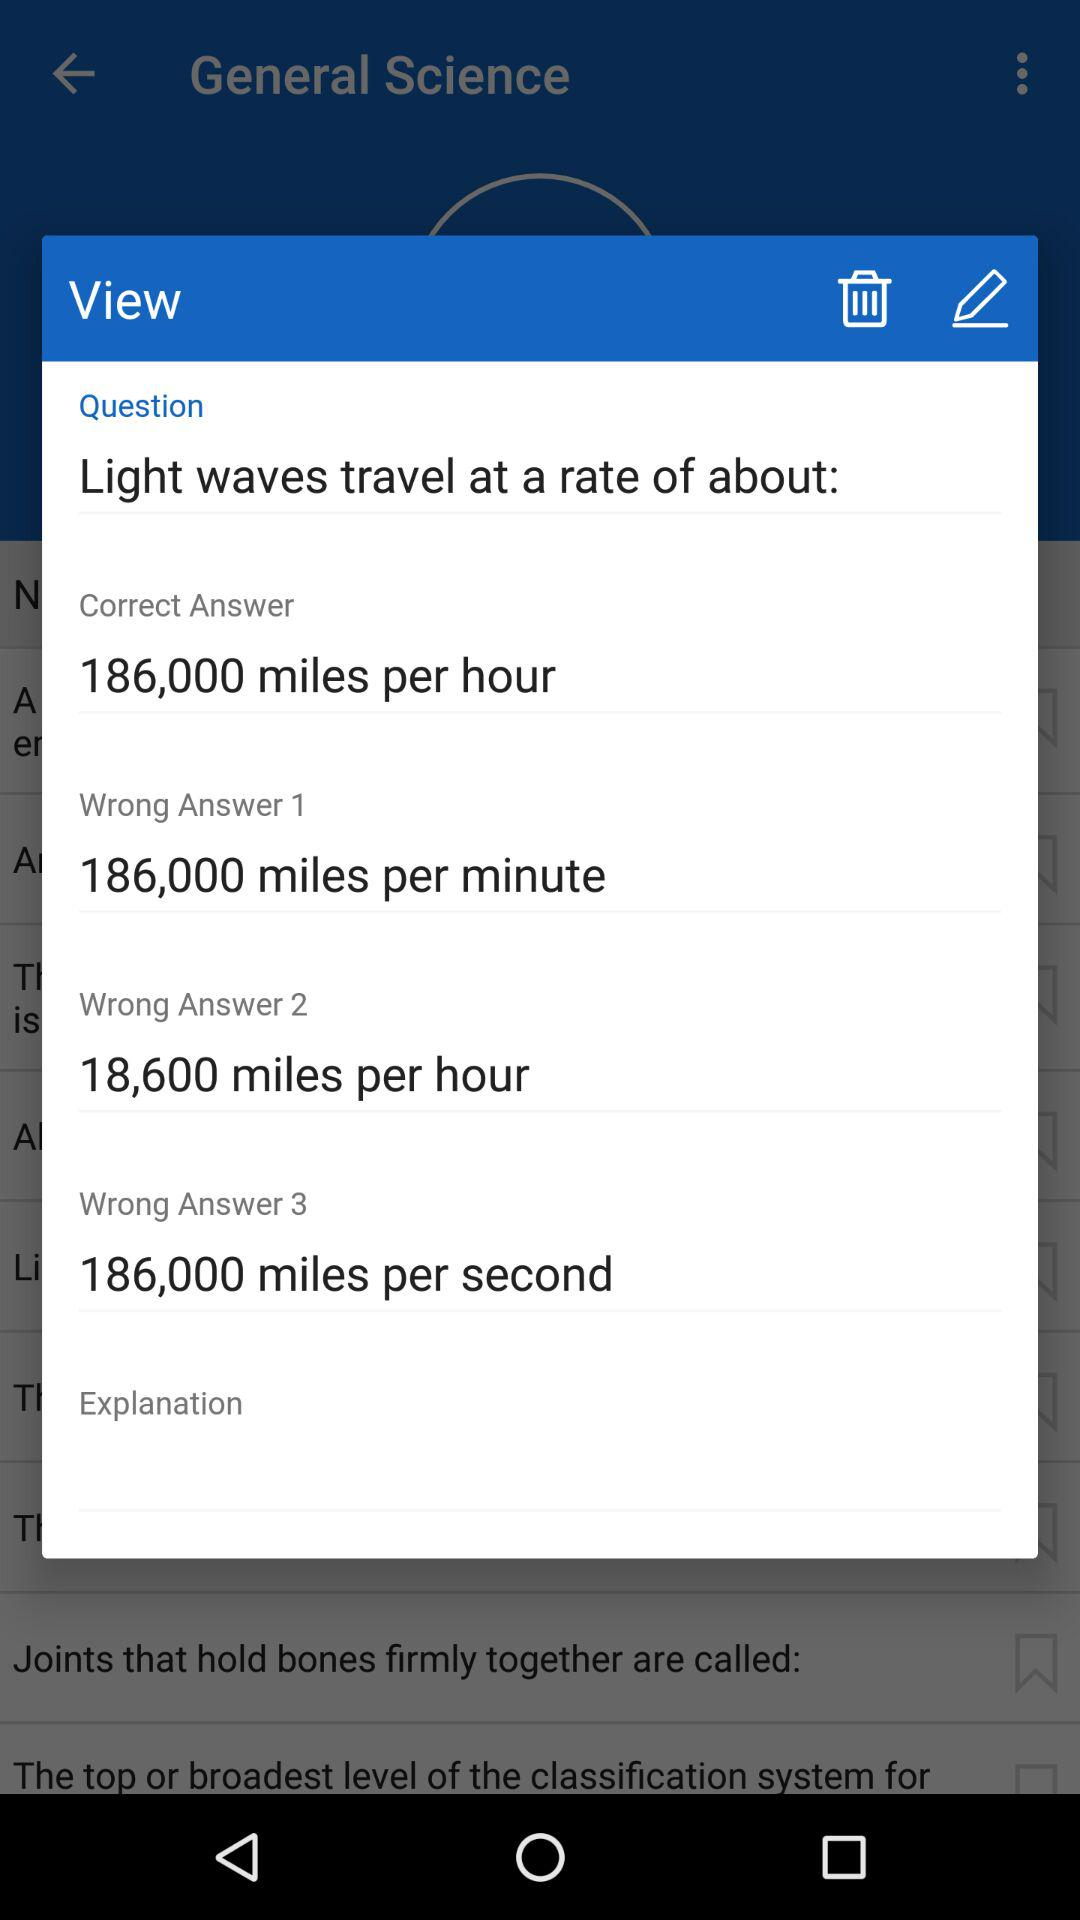What is the "Wrong Answer 1"? The "Wrong Answer 1" is 186,000 miles per minute. 